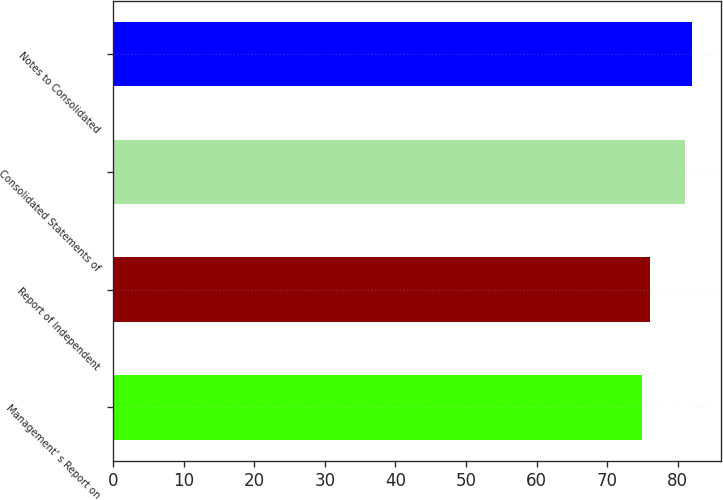Convert chart to OTSL. <chart><loc_0><loc_0><loc_500><loc_500><bar_chart><fcel>Management' s Report on<fcel>Report of Independent<fcel>Consolidated Statements of<fcel>Notes to Consolidated<nl><fcel>75<fcel>76<fcel>81<fcel>82<nl></chart> 